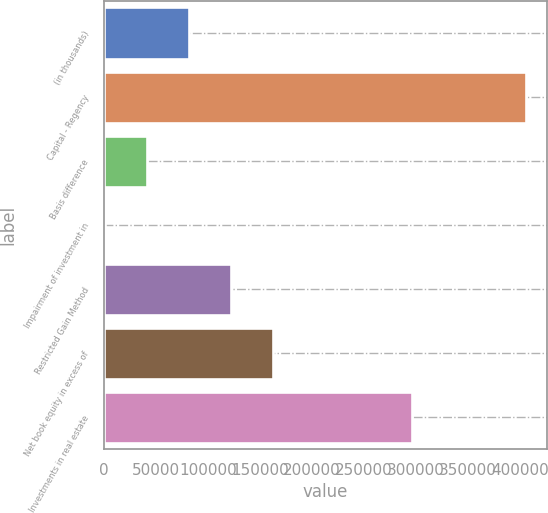Convert chart. <chart><loc_0><loc_0><loc_500><loc_500><bar_chart><fcel>(in thousands)<fcel>Capital - Regency<fcel>Basis difference<fcel>Impairment of investment in<fcel>Restricted Gain Method<fcel>Net book equity in excess of<fcel>Investments in real estate<nl><fcel>82184.4<fcel>405722<fcel>41742.2<fcel>1300<fcel>122627<fcel>163069<fcel>296699<nl></chart> 